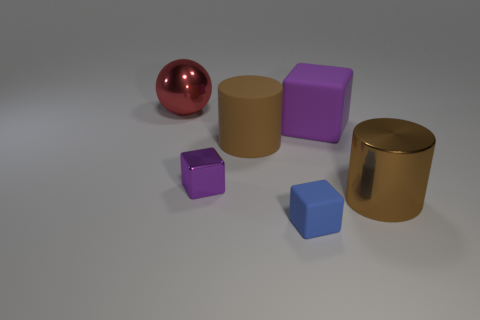Subtract all purple cubes. How many cubes are left? 1 Add 1 brown metallic cylinders. How many objects exist? 7 Subtract all blue cubes. How many cubes are left? 2 Add 1 large brown metallic things. How many large brown metallic things are left? 2 Add 5 brown metallic cylinders. How many brown metallic cylinders exist? 6 Subtract 0 red cylinders. How many objects are left? 6 Subtract all balls. How many objects are left? 5 Subtract 1 balls. How many balls are left? 0 Subtract all cyan cubes. Subtract all brown cylinders. How many cubes are left? 3 Subtract all cyan blocks. How many cyan cylinders are left? 0 